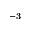<formula> <loc_0><loc_0><loc_500><loc_500>^ { - 3 }</formula> 